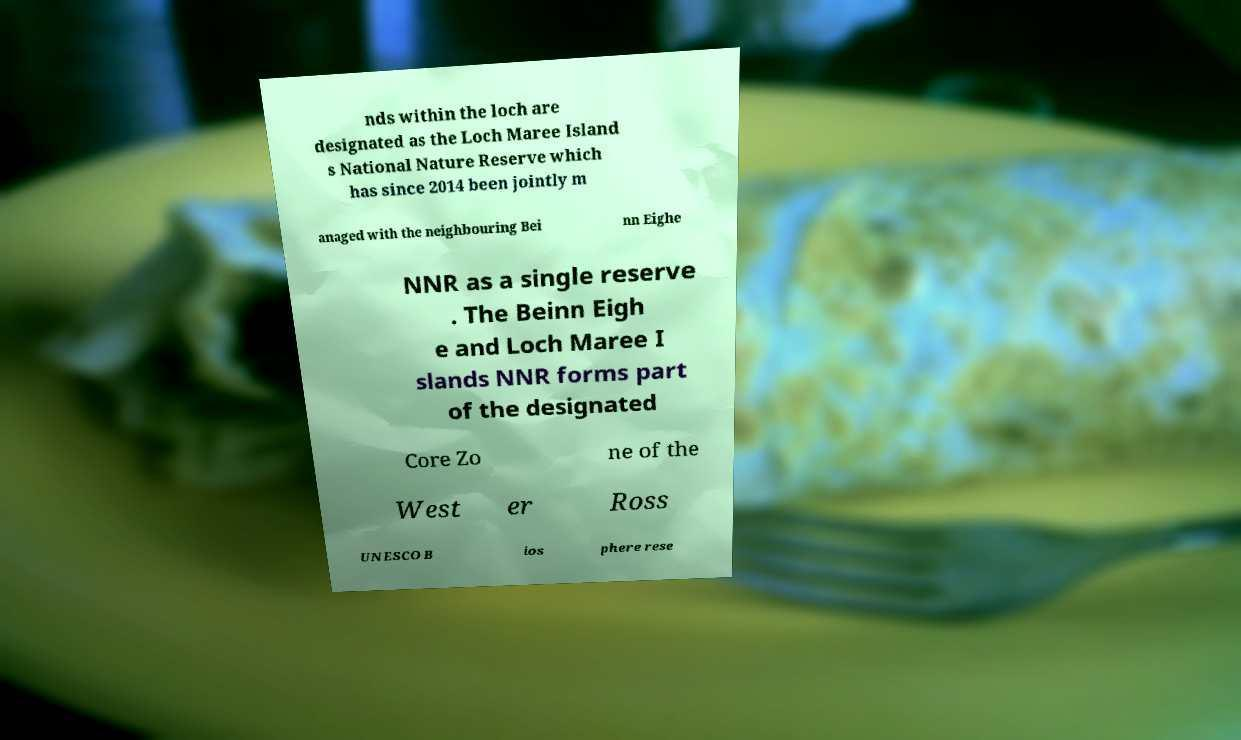For documentation purposes, I need the text within this image transcribed. Could you provide that? nds within the loch are designated as the Loch Maree Island s National Nature Reserve which has since 2014 been jointly m anaged with the neighbouring Bei nn Eighe NNR as a single reserve . The Beinn Eigh e and Loch Maree I slands NNR forms part of the designated Core Zo ne of the West er Ross UNESCO B ios phere rese 